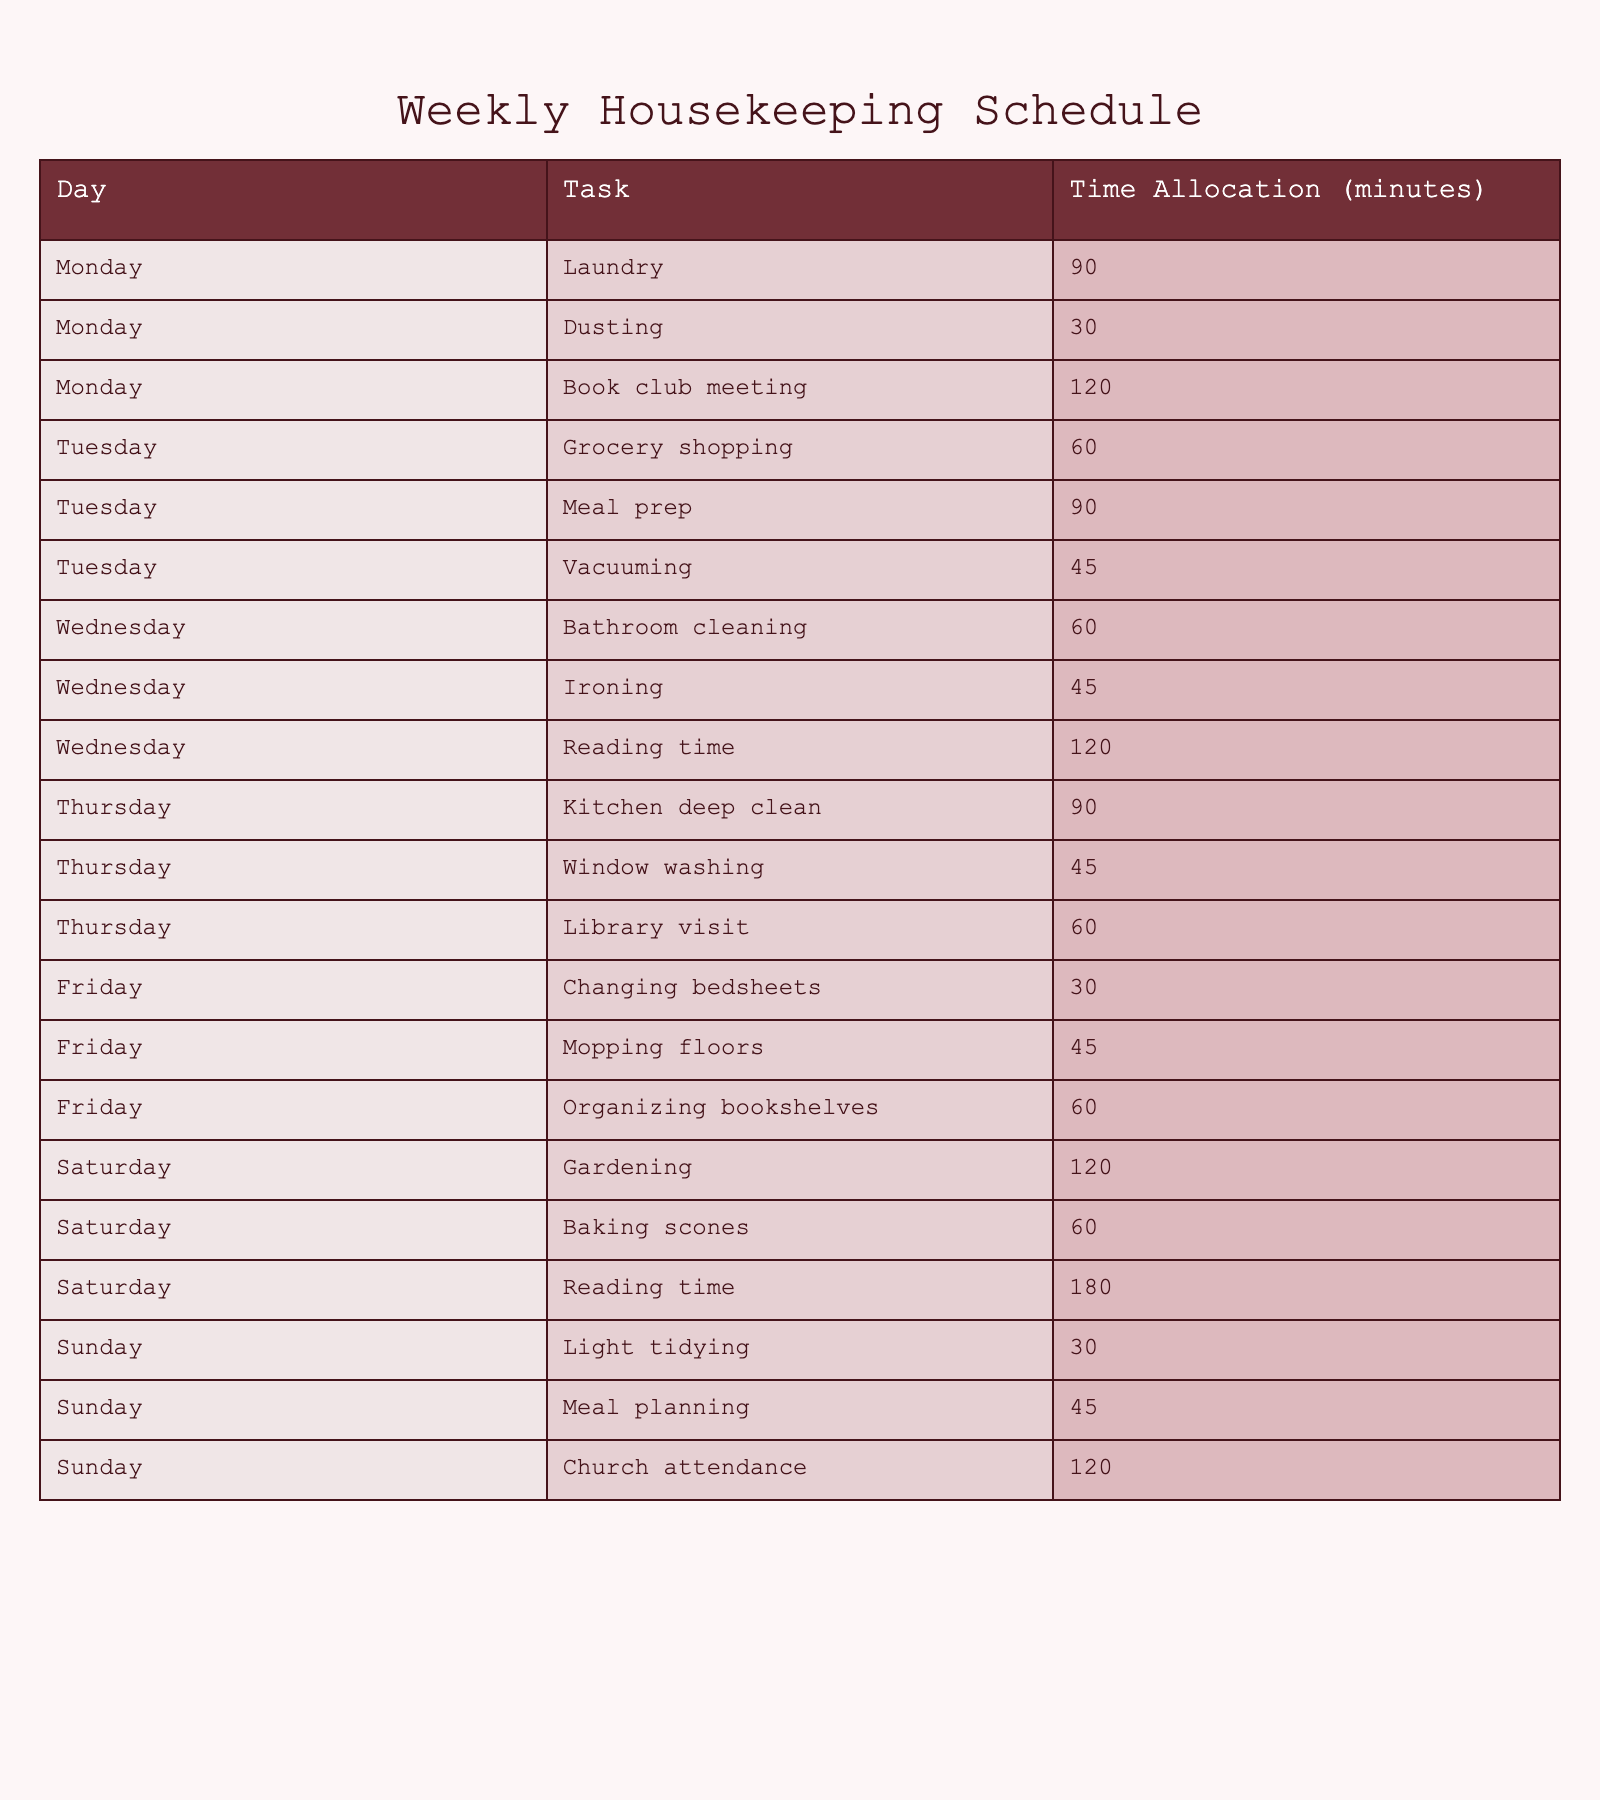What is the total time allocated for reading time? In the table, reading time appears on Wednesday (120 minutes) and Saturday (180 minutes). Summing these amounts gives 120 + 180 = 300 minutes.
Answer: 300 minutes Which day has the longest individual task duration? By reviewing the table, Saturday has Gardening for 120 minutes and Baking scones for 60 minutes, and Wednesday has Reading time for 120 minutes. Hence, the longest task is 120 minutes.
Answer: Saturday and Wednesday (both have 120 minutes) On which day is the total housekeeping time the least? We calculate the total for each day: Monday (240), Tuesday (195), Wednesday (225), Thursday (195), Friday (135), Saturday (360), and Sunday (195). The least total is Friday with 135 minutes.
Answer: Friday How many tasks involve reading? In the table, there are two tasks related to reading: Wednesday has Reading time and Saturday also lists Reading time. Thus, there are two tasks.
Answer: 2 tasks Is there a day when the laundry task is scheduled? The table shows that Monday has a laundry task scheduled for 90 minutes. Therefore, yes, laundry is scheduled on that day.
Answer: Yes What is the average time allocated for all housekeeping tasks on Sunday? The tasks on Sunday are Light tidying (30 minutes), Meal planning (45 minutes), and Church attendance (120 minutes). The total time is 30 + 45 + 120 = 195 minutes. Dividing by the number of tasks (3), we find the average is 195 / 3 = 65 minutes.
Answer: 65 minutes Which day has a library visit and how long is it allocated? The table indicates that Thursday includes a library visit, which is allocated for 60 minutes.
Answer: Thursday, 60 minutes What is the difference in total time allocation between Saturday and Friday? Saturday's total housekeeping time is 360 minutes (Gardening + Baking scones + Reading time), while Friday's total is 135 minutes. The difference is 360 - 135 = 225 minutes.
Answer: 225 minutes How many tasks are assigned a time greater than 60 minutes on Tuesday? On Tuesday, the tasks are Grocery shopping (60), Meal prep (90), and Vacuuming (45). Here, only Meal prep exceeds 60 minutes, so there is one task.
Answer: 1 task 